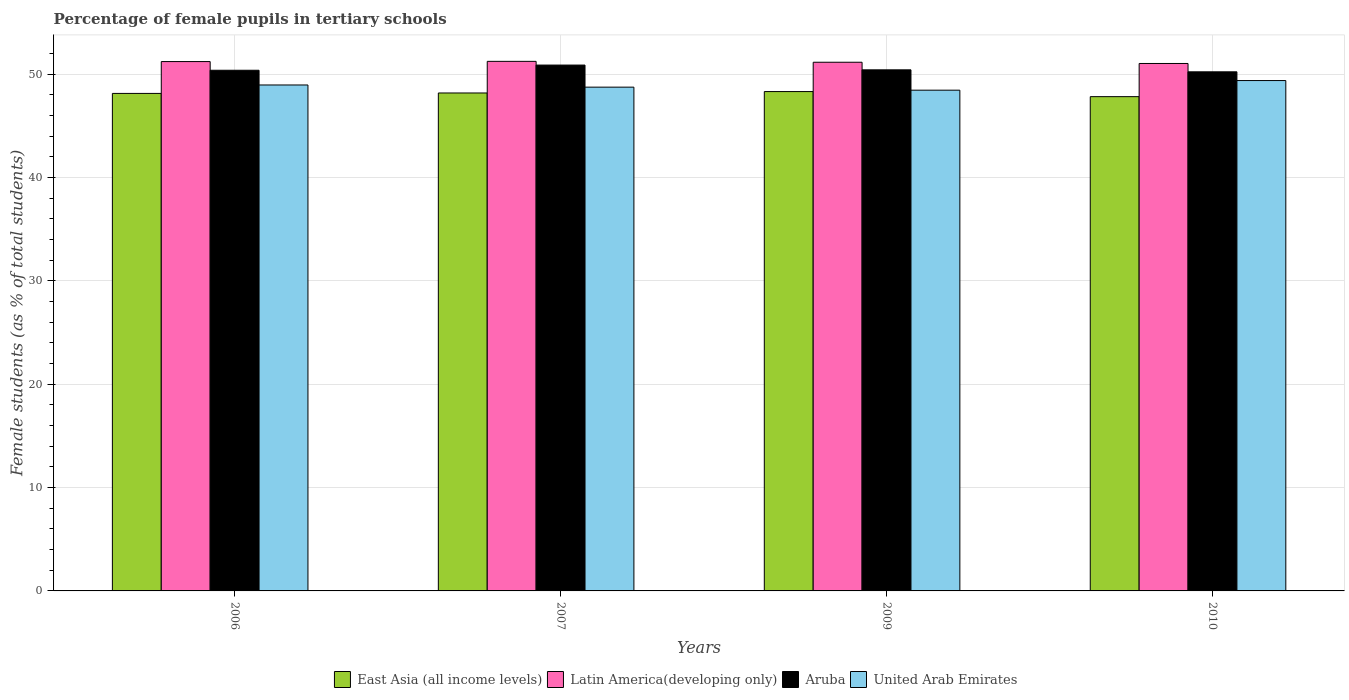How many different coloured bars are there?
Your answer should be very brief. 4. How many groups of bars are there?
Offer a very short reply. 4. Are the number of bars per tick equal to the number of legend labels?
Provide a short and direct response. Yes. How many bars are there on the 4th tick from the left?
Your answer should be compact. 4. What is the percentage of female pupils in tertiary schools in Aruba in 2009?
Offer a terse response. 50.42. Across all years, what is the maximum percentage of female pupils in tertiary schools in United Arab Emirates?
Your response must be concise. 49.39. Across all years, what is the minimum percentage of female pupils in tertiary schools in Latin America(developing only)?
Keep it short and to the point. 51.04. In which year was the percentage of female pupils in tertiary schools in Aruba maximum?
Make the answer very short. 2007. What is the total percentage of female pupils in tertiary schools in Aruba in the graph?
Your answer should be very brief. 201.92. What is the difference between the percentage of female pupils in tertiary schools in United Arab Emirates in 2007 and that in 2010?
Keep it short and to the point. -0.64. What is the difference between the percentage of female pupils in tertiary schools in United Arab Emirates in 2010 and the percentage of female pupils in tertiary schools in Aruba in 2009?
Provide a short and direct response. -1.04. What is the average percentage of female pupils in tertiary schools in East Asia (all income levels) per year?
Make the answer very short. 48.12. In the year 2010, what is the difference between the percentage of female pupils in tertiary schools in United Arab Emirates and percentage of female pupils in tertiary schools in Aruba?
Your answer should be very brief. -0.84. What is the ratio of the percentage of female pupils in tertiary schools in Aruba in 2006 to that in 2010?
Your answer should be very brief. 1. Is the percentage of female pupils in tertiary schools in United Arab Emirates in 2007 less than that in 2010?
Your answer should be very brief. Yes. Is the difference between the percentage of female pupils in tertiary schools in United Arab Emirates in 2006 and 2007 greater than the difference between the percentage of female pupils in tertiary schools in Aruba in 2006 and 2007?
Offer a terse response. Yes. What is the difference between the highest and the second highest percentage of female pupils in tertiary schools in East Asia (all income levels)?
Keep it short and to the point. 0.14. What is the difference between the highest and the lowest percentage of female pupils in tertiary schools in Latin America(developing only)?
Offer a terse response. 0.21. In how many years, is the percentage of female pupils in tertiary schools in Latin America(developing only) greater than the average percentage of female pupils in tertiary schools in Latin America(developing only) taken over all years?
Provide a short and direct response. 2. Is it the case that in every year, the sum of the percentage of female pupils in tertiary schools in United Arab Emirates and percentage of female pupils in tertiary schools in East Asia (all income levels) is greater than the sum of percentage of female pupils in tertiary schools in Latin America(developing only) and percentage of female pupils in tertiary schools in Aruba?
Offer a terse response. No. What does the 4th bar from the left in 2007 represents?
Provide a succinct answer. United Arab Emirates. What does the 3rd bar from the right in 2009 represents?
Your answer should be very brief. Latin America(developing only). Is it the case that in every year, the sum of the percentage of female pupils in tertiary schools in Aruba and percentage of female pupils in tertiary schools in Latin America(developing only) is greater than the percentage of female pupils in tertiary schools in United Arab Emirates?
Your answer should be very brief. Yes. How many bars are there?
Keep it short and to the point. 16. Are all the bars in the graph horizontal?
Offer a very short reply. No. Are the values on the major ticks of Y-axis written in scientific E-notation?
Keep it short and to the point. No. Does the graph contain any zero values?
Provide a short and direct response. No. Does the graph contain grids?
Keep it short and to the point. Yes. Where does the legend appear in the graph?
Offer a terse response. Bottom center. How many legend labels are there?
Your answer should be compact. 4. How are the legend labels stacked?
Keep it short and to the point. Horizontal. What is the title of the graph?
Make the answer very short. Percentage of female pupils in tertiary schools. What is the label or title of the Y-axis?
Make the answer very short. Female students (as % of total students). What is the Female students (as % of total students) of East Asia (all income levels) in 2006?
Offer a terse response. 48.14. What is the Female students (as % of total students) in Latin America(developing only) in 2006?
Your answer should be compact. 51.22. What is the Female students (as % of total students) in Aruba in 2006?
Give a very brief answer. 50.38. What is the Female students (as % of total students) in United Arab Emirates in 2006?
Give a very brief answer. 48.96. What is the Female students (as % of total students) of East Asia (all income levels) in 2007?
Give a very brief answer. 48.18. What is the Female students (as % of total students) of Latin America(developing only) in 2007?
Ensure brevity in your answer.  51.24. What is the Female students (as % of total students) in Aruba in 2007?
Ensure brevity in your answer.  50.89. What is the Female students (as % of total students) of United Arab Emirates in 2007?
Make the answer very short. 48.75. What is the Female students (as % of total students) of East Asia (all income levels) in 2009?
Offer a terse response. 48.32. What is the Female students (as % of total students) in Latin America(developing only) in 2009?
Provide a succinct answer. 51.16. What is the Female students (as % of total students) in Aruba in 2009?
Provide a short and direct response. 50.42. What is the Female students (as % of total students) of United Arab Emirates in 2009?
Keep it short and to the point. 48.46. What is the Female students (as % of total students) of East Asia (all income levels) in 2010?
Keep it short and to the point. 47.83. What is the Female students (as % of total students) of Latin America(developing only) in 2010?
Offer a very short reply. 51.04. What is the Female students (as % of total students) in Aruba in 2010?
Your answer should be compact. 50.23. What is the Female students (as % of total students) of United Arab Emirates in 2010?
Your answer should be very brief. 49.39. Across all years, what is the maximum Female students (as % of total students) of East Asia (all income levels)?
Provide a short and direct response. 48.32. Across all years, what is the maximum Female students (as % of total students) in Latin America(developing only)?
Offer a terse response. 51.24. Across all years, what is the maximum Female students (as % of total students) in Aruba?
Your response must be concise. 50.89. Across all years, what is the maximum Female students (as % of total students) of United Arab Emirates?
Your response must be concise. 49.39. Across all years, what is the minimum Female students (as % of total students) in East Asia (all income levels)?
Offer a very short reply. 47.83. Across all years, what is the minimum Female students (as % of total students) of Latin America(developing only)?
Keep it short and to the point. 51.04. Across all years, what is the minimum Female students (as % of total students) of Aruba?
Offer a very short reply. 50.23. Across all years, what is the minimum Female students (as % of total students) of United Arab Emirates?
Ensure brevity in your answer.  48.46. What is the total Female students (as % of total students) of East Asia (all income levels) in the graph?
Your answer should be compact. 192.48. What is the total Female students (as % of total students) of Latin America(developing only) in the graph?
Make the answer very short. 204.67. What is the total Female students (as % of total students) of Aruba in the graph?
Your response must be concise. 201.92. What is the total Female students (as % of total students) in United Arab Emirates in the graph?
Your answer should be compact. 195.55. What is the difference between the Female students (as % of total students) of East Asia (all income levels) in 2006 and that in 2007?
Make the answer very short. -0.04. What is the difference between the Female students (as % of total students) of Latin America(developing only) in 2006 and that in 2007?
Offer a very short reply. -0.02. What is the difference between the Female students (as % of total students) in Aruba in 2006 and that in 2007?
Offer a very short reply. -0.5. What is the difference between the Female students (as % of total students) of United Arab Emirates in 2006 and that in 2007?
Your response must be concise. 0.21. What is the difference between the Female students (as % of total students) of East Asia (all income levels) in 2006 and that in 2009?
Make the answer very short. -0.18. What is the difference between the Female students (as % of total students) in Latin America(developing only) in 2006 and that in 2009?
Give a very brief answer. 0.07. What is the difference between the Female students (as % of total students) of Aruba in 2006 and that in 2009?
Your answer should be very brief. -0.04. What is the difference between the Female students (as % of total students) of United Arab Emirates in 2006 and that in 2009?
Give a very brief answer. 0.5. What is the difference between the Female students (as % of total students) in East Asia (all income levels) in 2006 and that in 2010?
Ensure brevity in your answer.  0.31. What is the difference between the Female students (as % of total students) of Latin America(developing only) in 2006 and that in 2010?
Provide a succinct answer. 0.18. What is the difference between the Female students (as % of total students) in Aruba in 2006 and that in 2010?
Your answer should be compact. 0.15. What is the difference between the Female students (as % of total students) in United Arab Emirates in 2006 and that in 2010?
Provide a succinct answer. -0.43. What is the difference between the Female students (as % of total students) in East Asia (all income levels) in 2007 and that in 2009?
Provide a short and direct response. -0.14. What is the difference between the Female students (as % of total students) of Latin America(developing only) in 2007 and that in 2009?
Offer a terse response. 0.09. What is the difference between the Female students (as % of total students) of Aruba in 2007 and that in 2009?
Your answer should be very brief. 0.46. What is the difference between the Female students (as % of total students) of United Arab Emirates in 2007 and that in 2009?
Your answer should be compact. 0.29. What is the difference between the Female students (as % of total students) in East Asia (all income levels) in 2007 and that in 2010?
Keep it short and to the point. 0.35. What is the difference between the Female students (as % of total students) in Latin America(developing only) in 2007 and that in 2010?
Offer a very short reply. 0.21. What is the difference between the Female students (as % of total students) of Aruba in 2007 and that in 2010?
Provide a short and direct response. 0.65. What is the difference between the Female students (as % of total students) in United Arab Emirates in 2007 and that in 2010?
Provide a succinct answer. -0.64. What is the difference between the Female students (as % of total students) in East Asia (all income levels) in 2009 and that in 2010?
Provide a succinct answer. 0.49. What is the difference between the Female students (as % of total students) in Latin America(developing only) in 2009 and that in 2010?
Ensure brevity in your answer.  0.12. What is the difference between the Female students (as % of total students) in Aruba in 2009 and that in 2010?
Give a very brief answer. 0.19. What is the difference between the Female students (as % of total students) in United Arab Emirates in 2009 and that in 2010?
Offer a very short reply. -0.93. What is the difference between the Female students (as % of total students) of East Asia (all income levels) in 2006 and the Female students (as % of total students) of Latin America(developing only) in 2007?
Offer a very short reply. -3.1. What is the difference between the Female students (as % of total students) in East Asia (all income levels) in 2006 and the Female students (as % of total students) in Aruba in 2007?
Offer a very short reply. -2.74. What is the difference between the Female students (as % of total students) in East Asia (all income levels) in 2006 and the Female students (as % of total students) in United Arab Emirates in 2007?
Provide a short and direct response. -0.61. What is the difference between the Female students (as % of total students) of Latin America(developing only) in 2006 and the Female students (as % of total students) of Aruba in 2007?
Your answer should be compact. 0.34. What is the difference between the Female students (as % of total students) of Latin America(developing only) in 2006 and the Female students (as % of total students) of United Arab Emirates in 2007?
Your answer should be very brief. 2.48. What is the difference between the Female students (as % of total students) of Aruba in 2006 and the Female students (as % of total students) of United Arab Emirates in 2007?
Your answer should be compact. 1.64. What is the difference between the Female students (as % of total students) in East Asia (all income levels) in 2006 and the Female students (as % of total students) in Latin America(developing only) in 2009?
Provide a short and direct response. -3.02. What is the difference between the Female students (as % of total students) of East Asia (all income levels) in 2006 and the Female students (as % of total students) of Aruba in 2009?
Provide a succinct answer. -2.28. What is the difference between the Female students (as % of total students) of East Asia (all income levels) in 2006 and the Female students (as % of total students) of United Arab Emirates in 2009?
Your response must be concise. -0.31. What is the difference between the Female students (as % of total students) of Latin America(developing only) in 2006 and the Female students (as % of total students) of Aruba in 2009?
Your answer should be very brief. 0.8. What is the difference between the Female students (as % of total students) in Latin America(developing only) in 2006 and the Female students (as % of total students) in United Arab Emirates in 2009?
Your response must be concise. 2.77. What is the difference between the Female students (as % of total students) of Aruba in 2006 and the Female students (as % of total students) of United Arab Emirates in 2009?
Ensure brevity in your answer.  1.93. What is the difference between the Female students (as % of total students) in East Asia (all income levels) in 2006 and the Female students (as % of total students) in Latin America(developing only) in 2010?
Offer a terse response. -2.9. What is the difference between the Female students (as % of total students) in East Asia (all income levels) in 2006 and the Female students (as % of total students) in Aruba in 2010?
Your answer should be very brief. -2.09. What is the difference between the Female students (as % of total students) in East Asia (all income levels) in 2006 and the Female students (as % of total students) in United Arab Emirates in 2010?
Ensure brevity in your answer.  -1.24. What is the difference between the Female students (as % of total students) in Latin America(developing only) in 2006 and the Female students (as % of total students) in United Arab Emirates in 2010?
Your response must be concise. 1.84. What is the difference between the Female students (as % of total students) in Aruba in 2006 and the Female students (as % of total students) in United Arab Emirates in 2010?
Your answer should be compact. 1. What is the difference between the Female students (as % of total students) of East Asia (all income levels) in 2007 and the Female students (as % of total students) of Latin America(developing only) in 2009?
Your answer should be compact. -2.97. What is the difference between the Female students (as % of total students) of East Asia (all income levels) in 2007 and the Female students (as % of total students) of Aruba in 2009?
Keep it short and to the point. -2.24. What is the difference between the Female students (as % of total students) of East Asia (all income levels) in 2007 and the Female students (as % of total students) of United Arab Emirates in 2009?
Provide a short and direct response. -0.27. What is the difference between the Female students (as % of total students) in Latin America(developing only) in 2007 and the Female students (as % of total students) in Aruba in 2009?
Give a very brief answer. 0.82. What is the difference between the Female students (as % of total students) of Latin America(developing only) in 2007 and the Female students (as % of total students) of United Arab Emirates in 2009?
Ensure brevity in your answer.  2.79. What is the difference between the Female students (as % of total students) of Aruba in 2007 and the Female students (as % of total students) of United Arab Emirates in 2009?
Your answer should be very brief. 2.43. What is the difference between the Female students (as % of total students) of East Asia (all income levels) in 2007 and the Female students (as % of total students) of Latin America(developing only) in 2010?
Your answer should be compact. -2.86. What is the difference between the Female students (as % of total students) of East Asia (all income levels) in 2007 and the Female students (as % of total students) of Aruba in 2010?
Keep it short and to the point. -2.05. What is the difference between the Female students (as % of total students) in East Asia (all income levels) in 2007 and the Female students (as % of total students) in United Arab Emirates in 2010?
Provide a succinct answer. -1.2. What is the difference between the Female students (as % of total students) in Latin America(developing only) in 2007 and the Female students (as % of total students) in Aruba in 2010?
Your answer should be compact. 1.01. What is the difference between the Female students (as % of total students) in Latin America(developing only) in 2007 and the Female students (as % of total students) in United Arab Emirates in 2010?
Provide a short and direct response. 1.86. What is the difference between the Female students (as % of total students) in Aruba in 2007 and the Female students (as % of total students) in United Arab Emirates in 2010?
Provide a short and direct response. 1.5. What is the difference between the Female students (as % of total students) of East Asia (all income levels) in 2009 and the Female students (as % of total students) of Latin America(developing only) in 2010?
Offer a terse response. -2.72. What is the difference between the Female students (as % of total students) of East Asia (all income levels) in 2009 and the Female students (as % of total students) of Aruba in 2010?
Your response must be concise. -1.91. What is the difference between the Female students (as % of total students) of East Asia (all income levels) in 2009 and the Female students (as % of total students) of United Arab Emirates in 2010?
Ensure brevity in your answer.  -1.07. What is the difference between the Female students (as % of total students) of Latin America(developing only) in 2009 and the Female students (as % of total students) of Aruba in 2010?
Make the answer very short. 0.93. What is the difference between the Female students (as % of total students) of Latin America(developing only) in 2009 and the Female students (as % of total students) of United Arab Emirates in 2010?
Give a very brief answer. 1.77. What is the difference between the Female students (as % of total students) in Aruba in 2009 and the Female students (as % of total students) in United Arab Emirates in 2010?
Provide a short and direct response. 1.04. What is the average Female students (as % of total students) in East Asia (all income levels) per year?
Your response must be concise. 48.12. What is the average Female students (as % of total students) in Latin America(developing only) per year?
Your answer should be very brief. 51.17. What is the average Female students (as % of total students) of Aruba per year?
Ensure brevity in your answer.  50.48. What is the average Female students (as % of total students) of United Arab Emirates per year?
Provide a short and direct response. 48.89. In the year 2006, what is the difference between the Female students (as % of total students) of East Asia (all income levels) and Female students (as % of total students) of Latin America(developing only)?
Give a very brief answer. -3.08. In the year 2006, what is the difference between the Female students (as % of total students) of East Asia (all income levels) and Female students (as % of total students) of Aruba?
Ensure brevity in your answer.  -2.24. In the year 2006, what is the difference between the Female students (as % of total students) of East Asia (all income levels) and Female students (as % of total students) of United Arab Emirates?
Ensure brevity in your answer.  -0.82. In the year 2006, what is the difference between the Female students (as % of total students) of Latin America(developing only) and Female students (as % of total students) of Aruba?
Your answer should be compact. 0.84. In the year 2006, what is the difference between the Female students (as % of total students) of Latin America(developing only) and Female students (as % of total students) of United Arab Emirates?
Offer a very short reply. 2.27. In the year 2006, what is the difference between the Female students (as % of total students) of Aruba and Female students (as % of total students) of United Arab Emirates?
Give a very brief answer. 1.42. In the year 2007, what is the difference between the Female students (as % of total students) in East Asia (all income levels) and Female students (as % of total students) in Latin America(developing only)?
Provide a short and direct response. -3.06. In the year 2007, what is the difference between the Female students (as % of total students) of East Asia (all income levels) and Female students (as % of total students) of Aruba?
Give a very brief answer. -2.7. In the year 2007, what is the difference between the Female students (as % of total students) in East Asia (all income levels) and Female students (as % of total students) in United Arab Emirates?
Your response must be concise. -0.56. In the year 2007, what is the difference between the Female students (as % of total students) of Latin America(developing only) and Female students (as % of total students) of Aruba?
Keep it short and to the point. 0.36. In the year 2007, what is the difference between the Female students (as % of total students) of Latin America(developing only) and Female students (as % of total students) of United Arab Emirates?
Keep it short and to the point. 2.5. In the year 2007, what is the difference between the Female students (as % of total students) in Aruba and Female students (as % of total students) in United Arab Emirates?
Make the answer very short. 2.14. In the year 2009, what is the difference between the Female students (as % of total students) of East Asia (all income levels) and Female students (as % of total students) of Latin America(developing only)?
Your response must be concise. -2.84. In the year 2009, what is the difference between the Female students (as % of total students) in East Asia (all income levels) and Female students (as % of total students) in Aruba?
Your answer should be compact. -2.1. In the year 2009, what is the difference between the Female students (as % of total students) of East Asia (all income levels) and Female students (as % of total students) of United Arab Emirates?
Keep it short and to the point. -0.14. In the year 2009, what is the difference between the Female students (as % of total students) in Latin America(developing only) and Female students (as % of total students) in Aruba?
Offer a very short reply. 0.74. In the year 2009, what is the difference between the Female students (as % of total students) in Latin America(developing only) and Female students (as % of total students) in United Arab Emirates?
Provide a short and direct response. 2.7. In the year 2009, what is the difference between the Female students (as % of total students) in Aruba and Female students (as % of total students) in United Arab Emirates?
Give a very brief answer. 1.97. In the year 2010, what is the difference between the Female students (as % of total students) of East Asia (all income levels) and Female students (as % of total students) of Latin America(developing only)?
Make the answer very short. -3.21. In the year 2010, what is the difference between the Female students (as % of total students) in East Asia (all income levels) and Female students (as % of total students) in Aruba?
Make the answer very short. -2.4. In the year 2010, what is the difference between the Female students (as % of total students) in East Asia (all income levels) and Female students (as % of total students) in United Arab Emirates?
Your response must be concise. -1.56. In the year 2010, what is the difference between the Female students (as % of total students) in Latin America(developing only) and Female students (as % of total students) in Aruba?
Ensure brevity in your answer.  0.81. In the year 2010, what is the difference between the Female students (as % of total students) of Latin America(developing only) and Female students (as % of total students) of United Arab Emirates?
Keep it short and to the point. 1.65. In the year 2010, what is the difference between the Female students (as % of total students) in Aruba and Female students (as % of total students) in United Arab Emirates?
Ensure brevity in your answer.  0.84. What is the ratio of the Female students (as % of total students) of East Asia (all income levels) in 2006 to that in 2007?
Offer a terse response. 1. What is the ratio of the Female students (as % of total students) in Latin America(developing only) in 2006 to that in 2007?
Provide a succinct answer. 1. What is the ratio of the Female students (as % of total students) of Aruba in 2006 to that in 2007?
Your response must be concise. 0.99. What is the ratio of the Female students (as % of total students) of Latin America(developing only) in 2006 to that in 2009?
Offer a very short reply. 1. What is the ratio of the Female students (as % of total students) in United Arab Emirates in 2006 to that in 2009?
Offer a very short reply. 1.01. What is the ratio of the Female students (as % of total students) in United Arab Emirates in 2006 to that in 2010?
Provide a succinct answer. 0.99. What is the ratio of the Female students (as % of total students) of Latin America(developing only) in 2007 to that in 2009?
Make the answer very short. 1. What is the ratio of the Female students (as % of total students) of Aruba in 2007 to that in 2009?
Ensure brevity in your answer.  1.01. What is the ratio of the Female students (as % of total students) in United Arab Emirates in 2007 to that in 2009?
Provide a short and direct response. 1.01. What is the ratio of the Female students (as % of total students) in East Asia (all income levels) in 2007 to that in 2010?
Offer a very short reply. 1.01. What is the ratio of the Female students (as % of total students) of Latin America(developing only) in 2007 to that in 2010?
Provide a succinct answer. 1. What is the ratio of the Female students (as % of total students) in Aruba in 2007 to that in 2010?
Ensure brevity in your answer.  1.01. What is the ratio of the Female students (as % of total students) of United Arab Emirates in 2007 to that in 2010?
Ensure brevity in your answer.  0.99. What is the ratio of the Female students (as % of total students) of East Asia (all income levels) in 2009 to that in 2010?
Make the answer very short. 1.01. What is the ratio of the Female students (as % of total students) in United Arab Emirates in 2009 to that in 2010?
Give a very brief answer. 0.98. What is the difference between the highest and the second highest Female students (as % of total students) of East Asia (all income levels)?
Your answer should be very brief. 0.14. What is the difference between the highest and the second highest Female students (as % of total students) of Latin America(developing only)?
Your answer should be very brief. 0.02. What is the difference between the highest and the second highest Female students (as % of total students) in Aruba?
Offer a very short reply. 0.46. What is the difference between the highest and the second highest Female students (as % of total students) in United Arab Emirates?
Keep it short and to the point. 0.43. What is the difference between the highest and the lowest Female students (as % of total students) of East Asia (all income levels)?
Provide a succinct answer. 0.49. What is the difference between the highest and the lowest Female students (as % of total students) in Latin America(developing only)?
Your answer should be very brief. 0.21. What is the difference between the highest and the lowest Female students (as % of total students) in Aruba?
Your response must be concise. 0.65. What is the difference between the highest and the lowest Female students (as % of total students) in United Arab Emirates?
Your answer should be very brief. 0.93. 